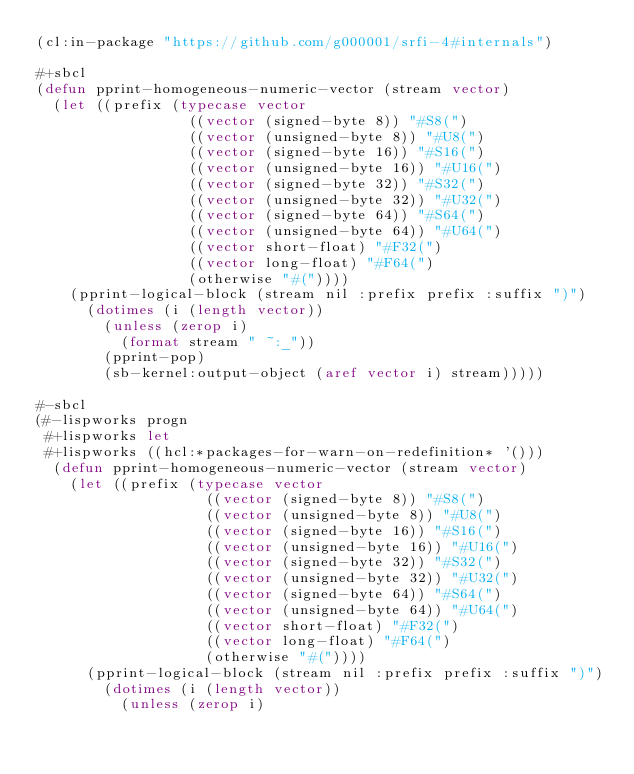Convert code to text. <code><loc_0><loc_0><loc_500><loc_500><_Lisp_>(cl:in-package "https://github.com/g000001/srfi-4#internals")

#+sbcl
(defun pprint-homogeneous-numeric-vector (stream vector)
  (let ((prefix (typecase vector
                  ((vector (signed-byte 8)) "#S8(")
                  ((vector (unsigned-byte 8)) "#U8(")
                  ((vector (signed-byte 16)) "#S16(")
                  ((vector (unsigned-byte 16)) "#U16(")
                  ((vector (signed-byte 32)) "#S32(")
                  ((vector (unsigned-byte 32)) "#U32(")
                  ((vector (signed-byte 64)) "#S64(")
                  ((vector (unsigned-byte 64)) "#U64(")
                  ((vector short-float) "#F32(")
                  ((vector long-float) "#F64(")
                  (otherwise "#("))))
    (pprint-logical-block (stream nil :prefix prefix :suffix ")")
      (dotimes (i (length vector))
        (unless (zerop i)
          (format stream " ~:_"))
        (pprint-pop)
        (sb-kernel:output-object (aref vector i) stream)))))

#-sbcl
(#-lispworks progn
 #+lispworks let
 #+lispworks ((hcl:*packages-for-warn-on-redefinition* '()))
  (defun pprint-homogeneous-numeric-vector (stream vector)
    (let ((prefix (typecase vector
                    ((vector (signed-byte 8)) "#S8(")
                    ((vector (unsigned-byte 8)) "#U8(")
                    ((vector (signed-byte 16)) "#S16(")
                    ((vector (unsigned-byte 16)) "#U16(")
                    ((vector (signed-byte 32)) "#S32(")
                    ((vector (unsigned-byte 32)) "#U32(")
                    ((vector (signed-byte 64)) "#S64(")
                    ((vector (unsigned-byte 64)) "#U64(")
                    ((vector short-float) "#F32(")
                    ((vector long-float) "#F64(")
                    (otherwise "#("))))
      (pprint-logical-block (stream nil :prefix prefix :suffix ")")
        (dotimes (i (length vector))
          (unless (zerop i)</code> 